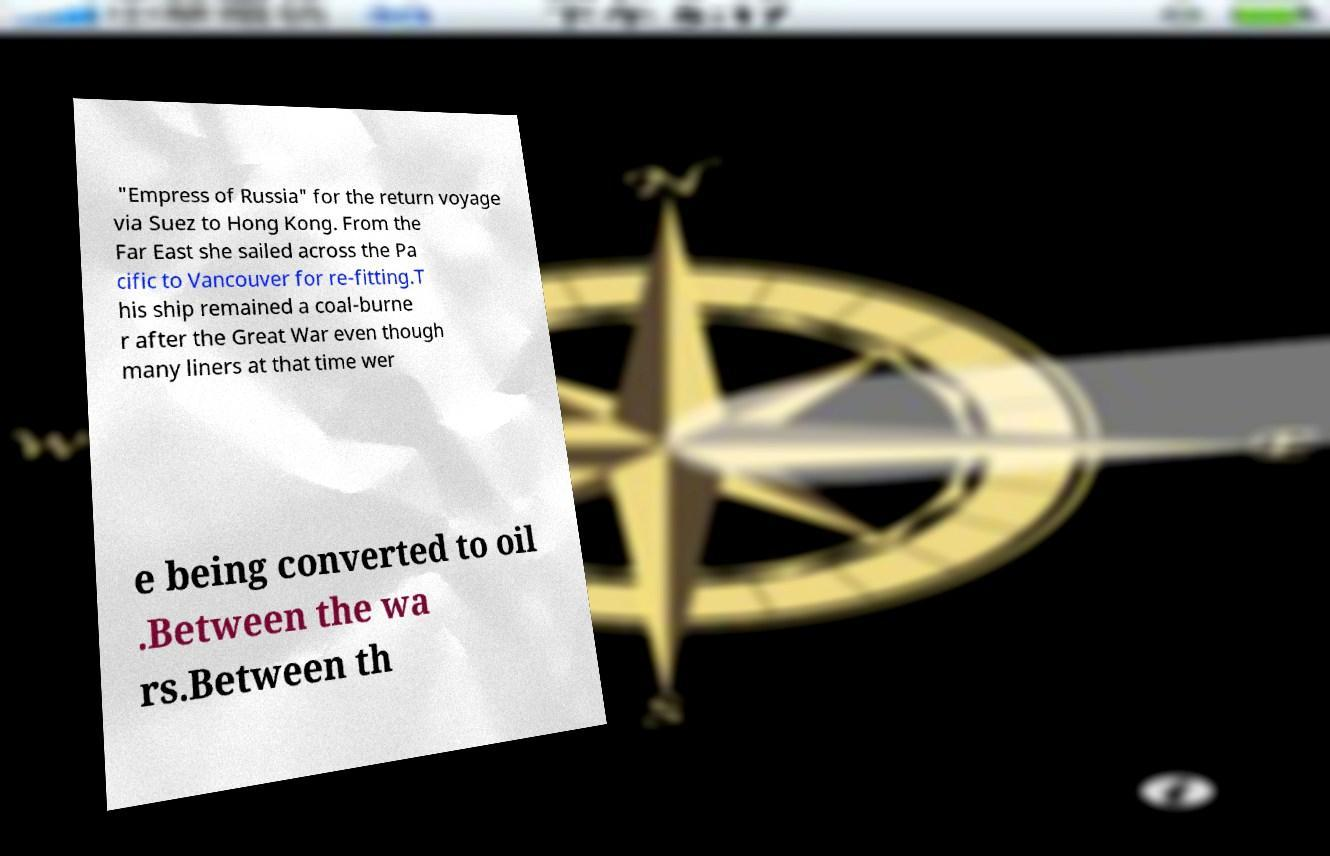Please identify and transcribe the text found in this image. "Empress of Russia" for the return voyage via Suez to Hong Kong. From the Far East she sailed across the Pa cific to Vancouver for re-fitting.T his ship remained a coal-burne r after the Great War even though many liners at that time wer e being converted to oil .Between the wa rs.Between th 